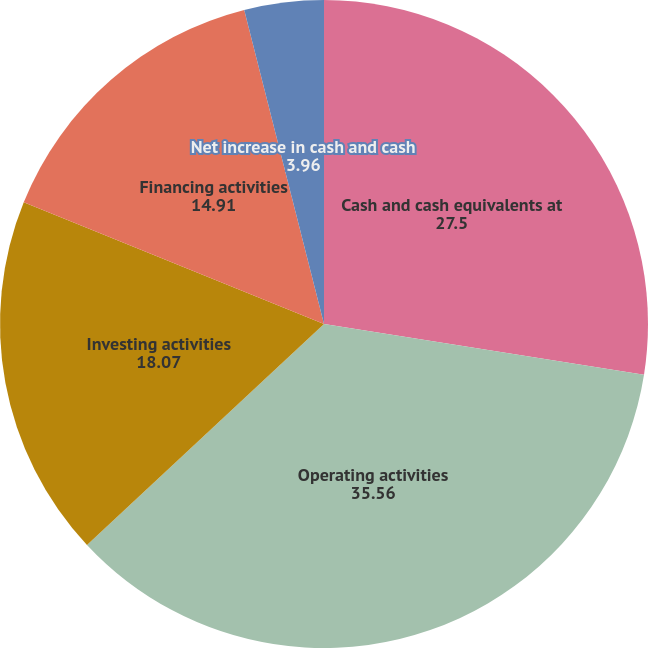Convert chart to OTSL. <chart><loc_0><loc_0><loc_500><loc_500><pie_chart><fcel>Cash and cash equivalents at<fcel>Operating activities<fcel>Investing activities<fcel>Financing activities<fcel>Net increase in cash and cash<nl><fcel>27.5%<fcel>35.56%<fcel>18.07%<fcel>14.91%<fcel>3.96%<nl></chart> 